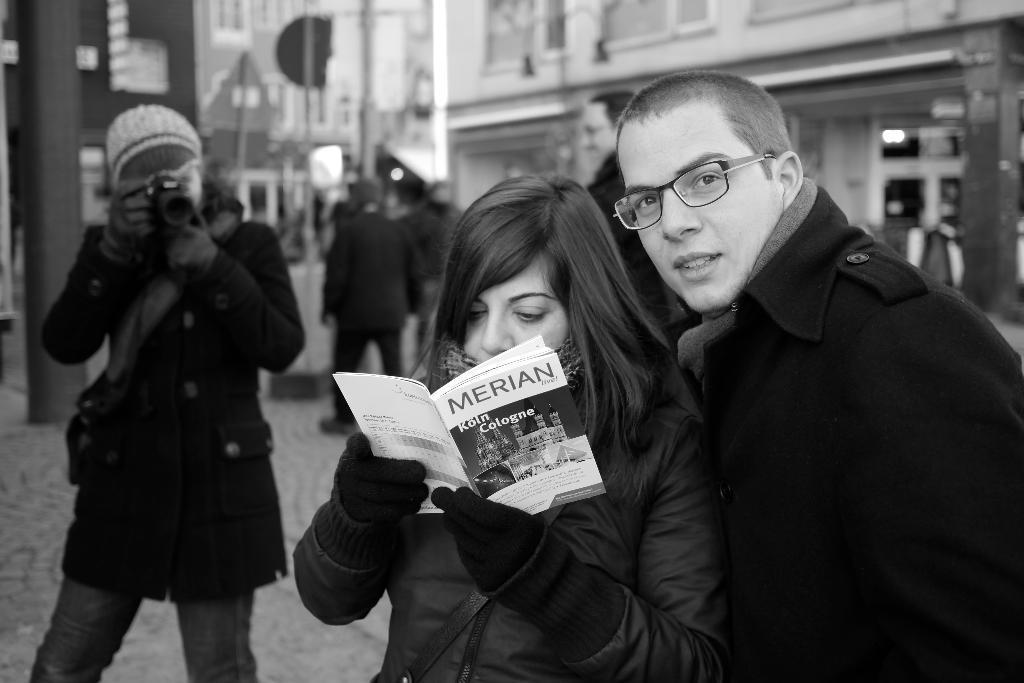Could you give a brief overview of what you see in this image? In the foreground of this black and image, there is a couple standing on the right and the woman is holding a book. On the left, there is a person holding a camera. In the background, there are few people and buildings. 